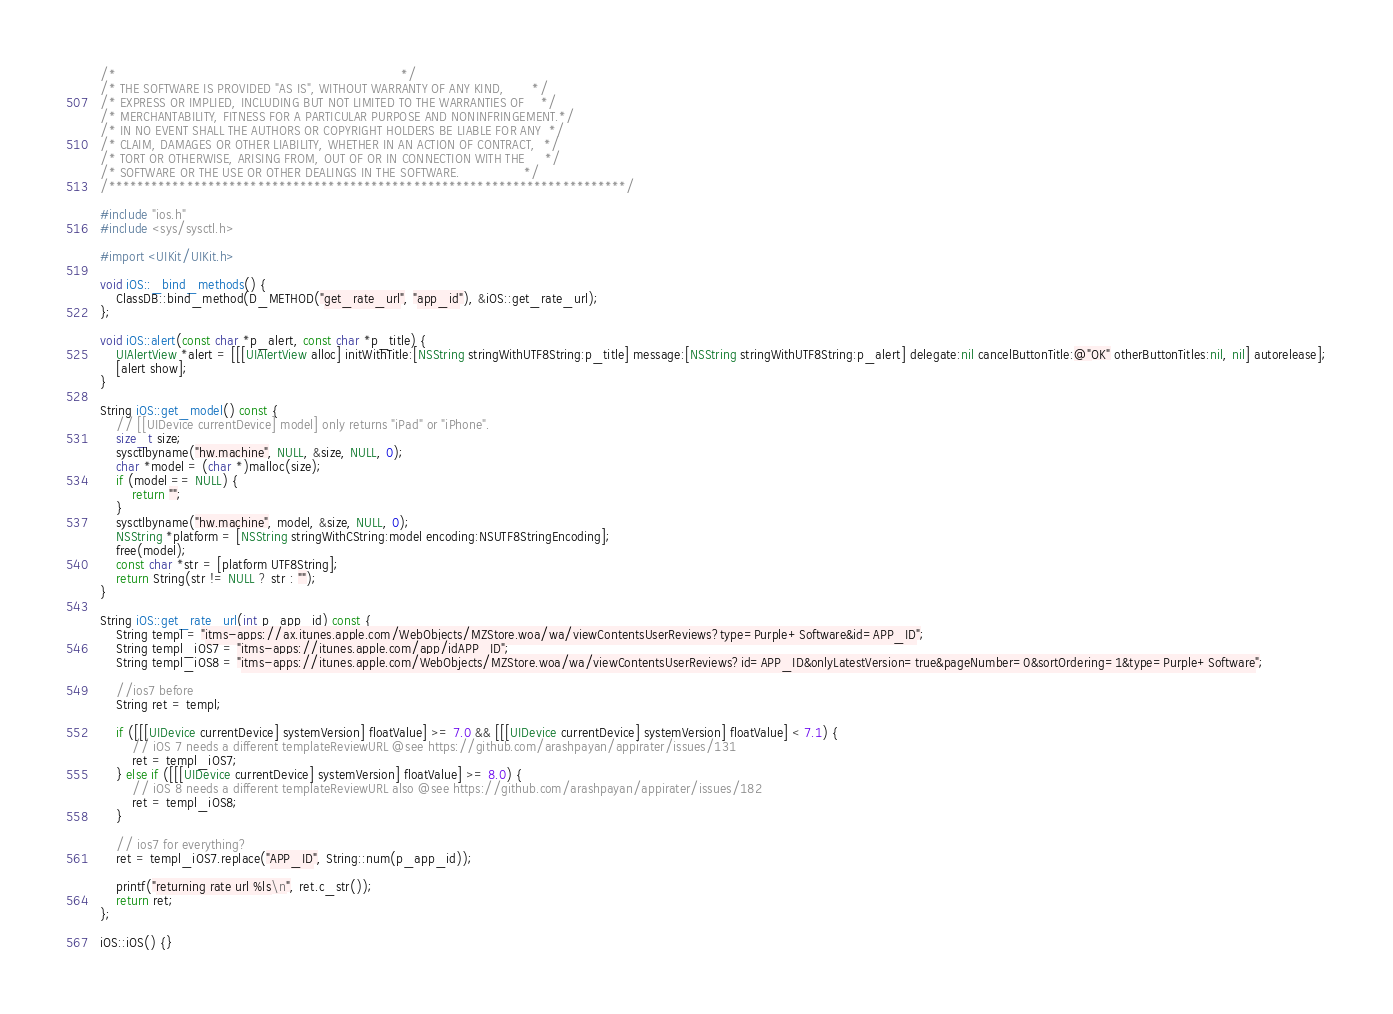<code> <loc_0><loc_0><loc_500><loc_500><_ObjectiveC_>/*                                                                       */
/* THE SOFTWARE IS PROVIDED "AS IS", WITHOUT WARRANTY OF ANY KIND,       */
/* EXPRESS OR IMPLIED, INCLUDING BUT NOT LIMITED TO THE WARRANTIES OF    */
/* MERCHANTABILITY, FITNESS FOR A PARTICULAR PURPOSE AND NONINFRINGEMENT.*/
/* IN NO EVENT SHALL THE AUTHORS OR COPYRIGHT HOLDERS BE LIABLE FOR ANY  */
/* CLAIM, DAMAGES OR OTHER LIABILITY, WHETHER IN AN ACTION OF CONTRACT,  */
/* TORT OR OTHERWISE, ARISING FROM, OUT OF OR IN CONNECTION WITH THE     */
/* SOFTWARE OR THE USE OR OTHER DEALINGS IN THE SOFTWARE.                */
/*************************************************************************/

#include "ios.h"
#include <sys/sysctl.h>

#import <UIKit/UIKit.h>

void iOS::_bind_methods() {
	ClassDB::bind_method(D_METHOD("get_rate_url", "app_id"), &iOS::get_rate_url);
};

void iOS::alert(const char *p_alert, const char *p_title) {
	UIAlertView *alert = [[[UIAlertView alloc] initWithTitle:[NSString stringWithUTF8String:p_title] message:[NSString stringWithUTF8String:p_alert] delegate:nil cancelButtonTitle:@"OK" otherButtonTitles:nil, nil] autorelease];
	[alert show];
}

String iOS::get_model() const {
	// [[UIDevice currentDevice] model] only returns "iPad" or "iPhone".
	size_t size;
	sysctlbyname("hw.machine", NULL, &size, NULL, 0);
	char *model = (char *)malloc(size);
	if (model == NULL) {
		return "";
	}
	sysctlbyname("hw.machine", model, &size, NULL, 0);
	NSString *platform = [NSString stringWithCString:model encoding:NSUTF8StringEncoding];
	free(model);
	const char *str = [platform UTF8String];
	return String(str != NULL ? str : "");
}

String iOS::get_rate_url(int p_app_id) const {
	String templ = "itms-apps://ax.itunes.apple.com/WebObjects/MZStore.woa/wa/viewContentsUserReviews?type=Purple+Software&id=APP_ID";
	String templ_iOS7 = "itms-apps://itunes.apple.com/app/idAPP_ID";
	String templ_iOS8 = "itms-apps://itunes.apple.com/WebObjects/MZStore.woa/wa/viewContentsUserReviews?id=APP_ID&onlyLatestVersion=true&pageNumber=0&sortOrdering=1&type=Purple+Software";

	//ios7 before
	String ret = templ;

	if ([[[UIDevice currentDevice] systemVersion] floatValue] >= 7.0 && [[[UIDevice currentDevice] systemVersion] floatValue] < 7.1) {
		// iOS 7 needs a different templateReviewURL @see https://github.com/arashpayan/appirater/issues/131
		ret = templ_iOS7;
	} else if ([[[UIDevice currentDevice] systemVersion] floatValue] >= 8.0) {
		// iOS 8 needs a different templateReviewURL also @see https://github.com/arashpayan/appirater/issues/182
		ret = templ_iOS8;
	}

	// ios7 for everything?
	ret = templ_iOS7.replace("APP_ID", String::num(p_app_id));

	printf("returning rate url %ls\n", ret.c_str());
	return ret;
};

iOS::iOS() {}
</code> 